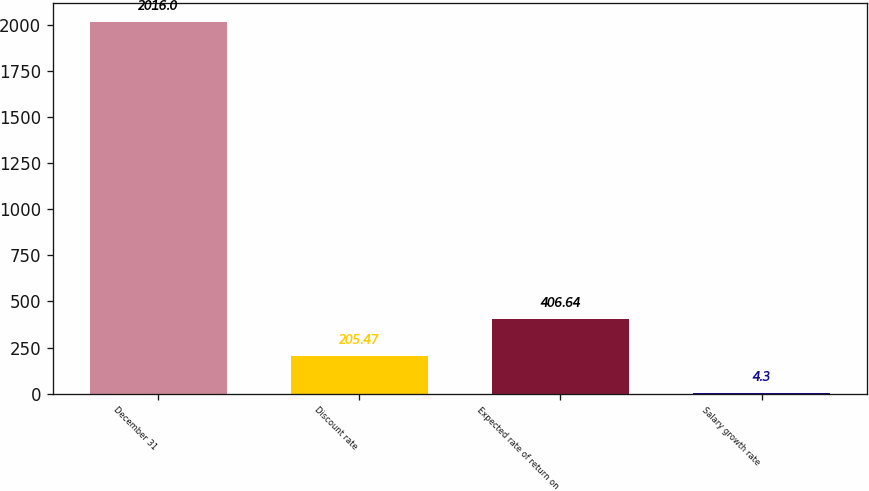<chart> <loc_0><loc_0><loc_500><loc_500><bar_chart><fcel>December 31<fcel>Discount rate<fcel>Expected rate of return on<fcel>Salary growth rate<nl><fcel>2016<fcel>205.47<fcel>406.64<fcel>4.3<nl></chart> 